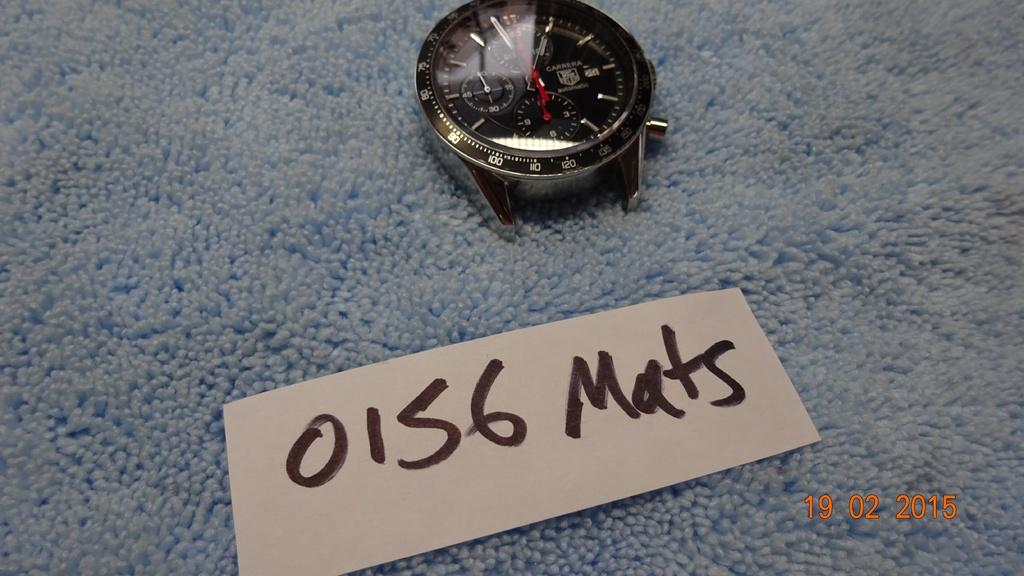<image>
Give a short and clear explanation of the subsequent image. A bandless a Cararera watch on a carpet with a handwritten card that is labeled 0156 Mats 